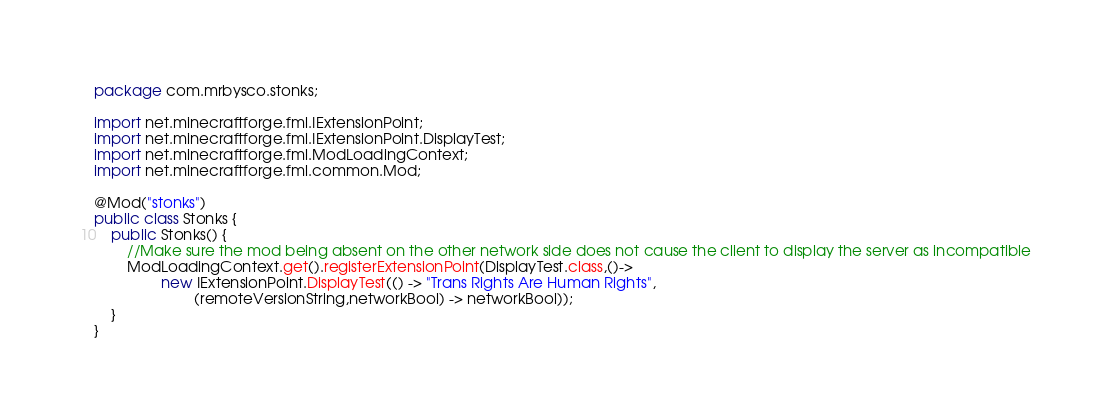<code> <loc_0><loc_0><loc_500><loc_500><_Java_>package com.mrbysco.stonks;

import net.minecraftforge.fml.IExtensionPoint;
import net.minecraftforge.fml.IExtensionPoint.DisplayTest;
import net.minecraftforge.fml.ModLoadingContext;
import net.minecraftforge.fml.common.Mod;

@Mod("stonks")
public class Stonks {
    public Stonks() {
        //Make sure the mod being absent on the other network side does not cause the client to display the server as incompatible
        ModLoadingContext.get().registerExtensionPoint(DisplayTest.class,()->
                new IExtensionPoint.DisplayTest(() -> "Trans Rights Are Human Rights",
                        (remoteVersionString,networkBool) -> networkBool));
    }
}
</code> 